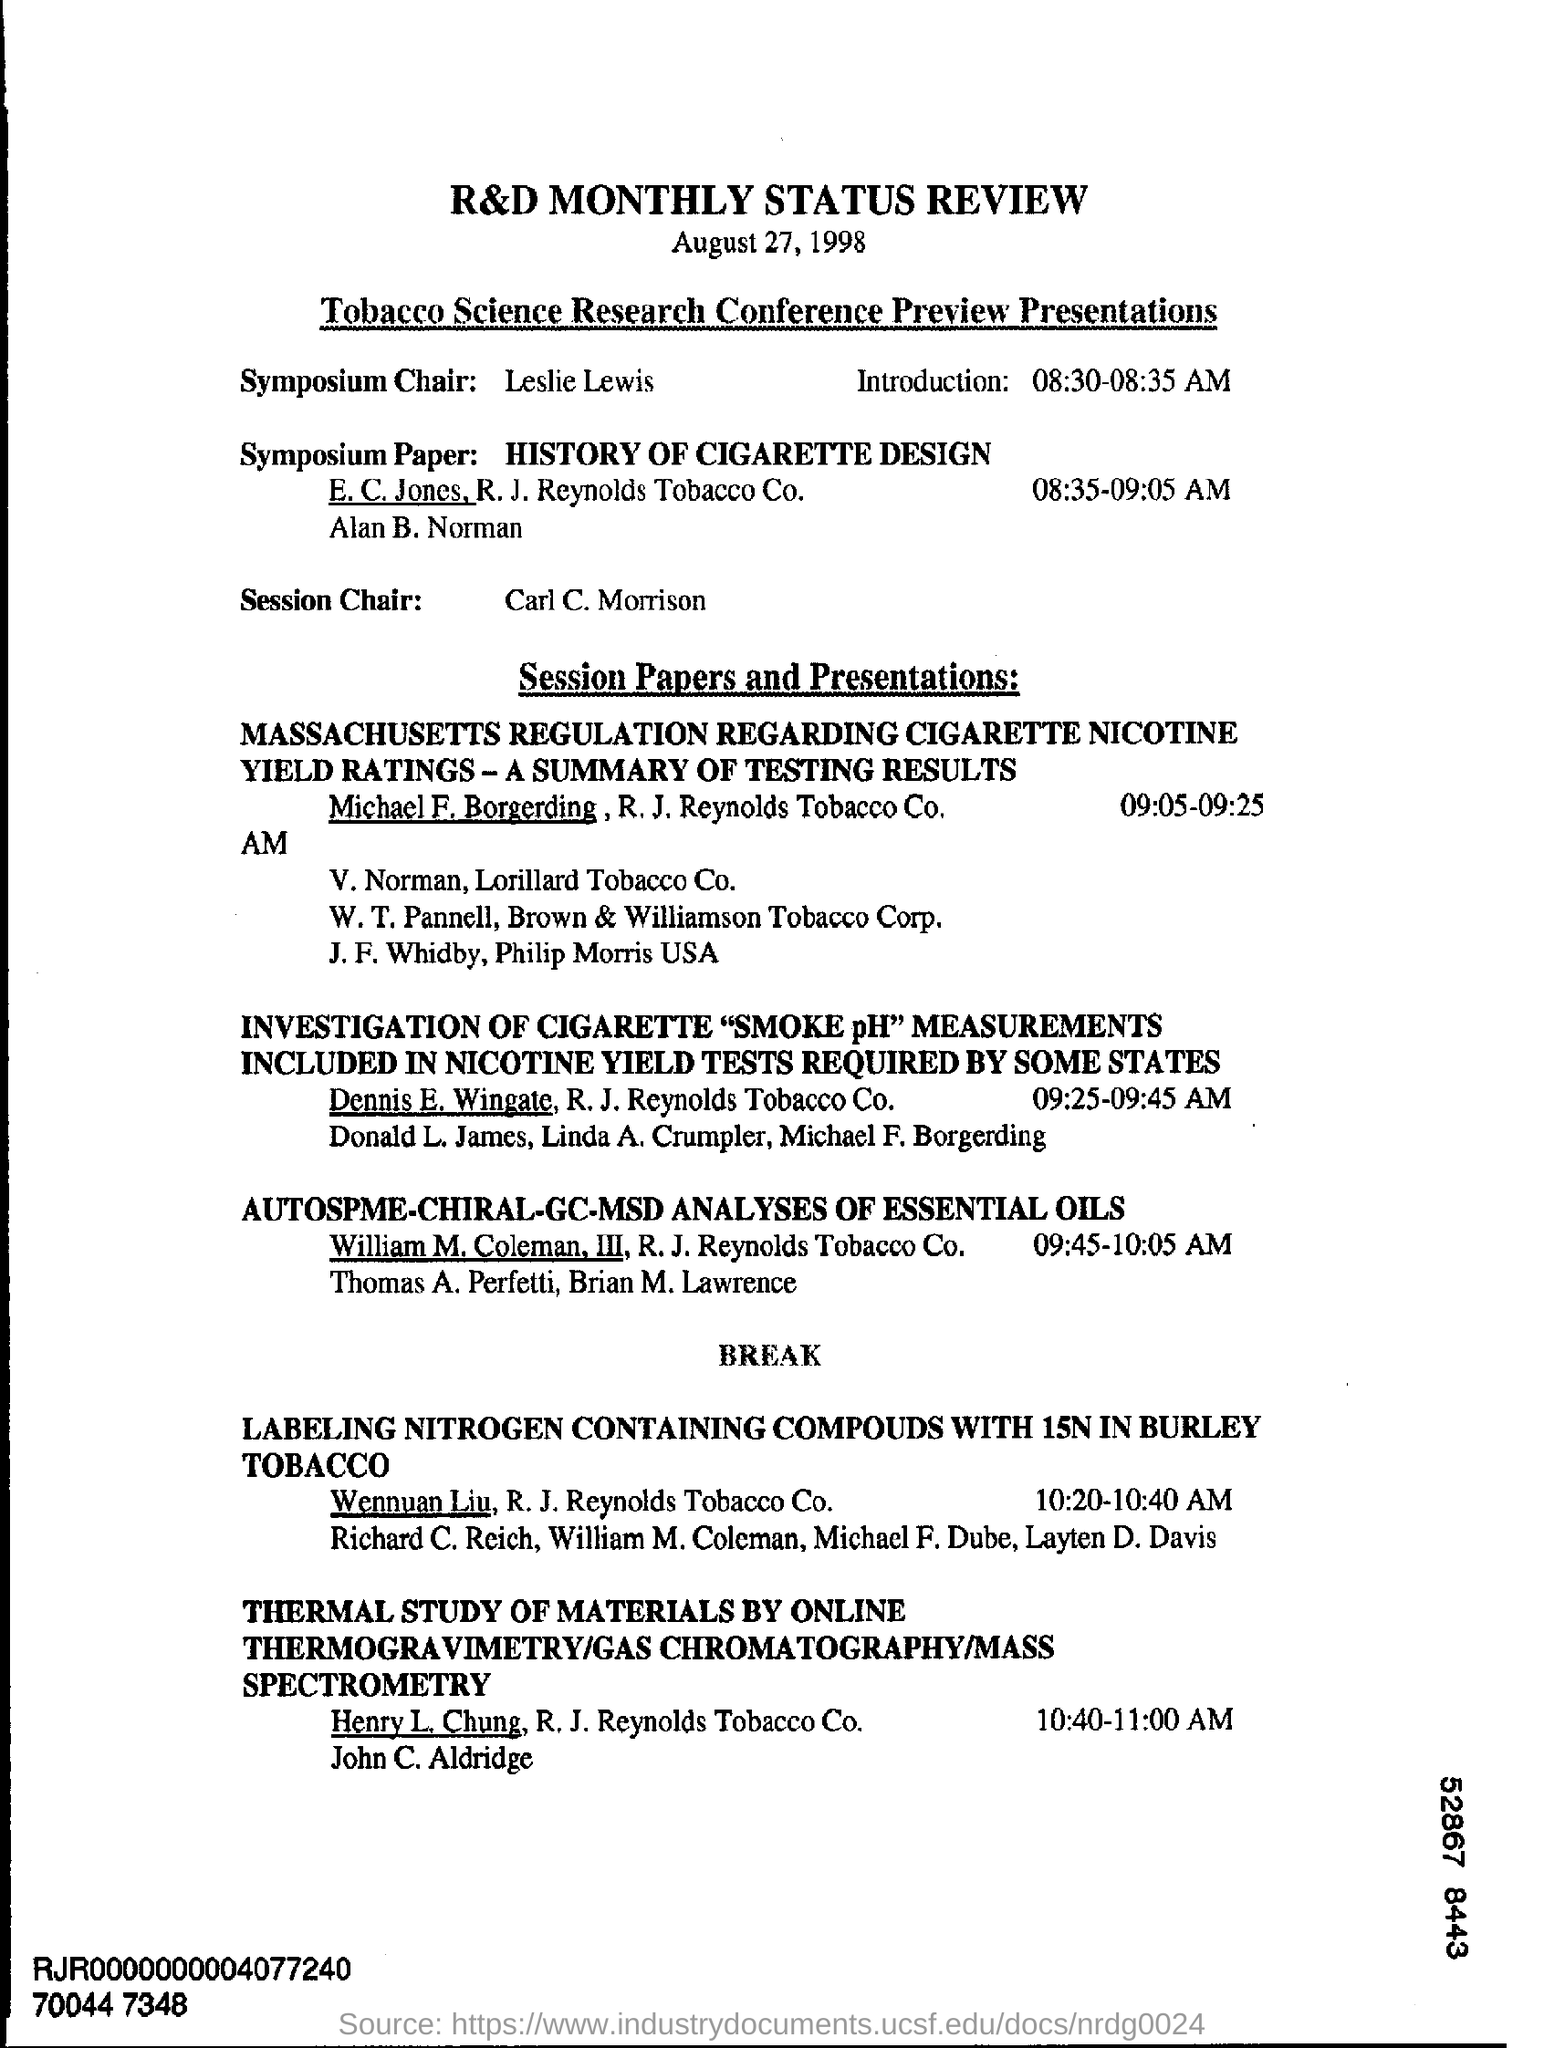What is the date mentioned?
Provide a short and direct response. August 27, 1998. Who is the Symposium Chair?
Your response must be concise. Leslie Lewis. Who is the Session Chair?
Your response must be concise. Carl C. Morrison. 